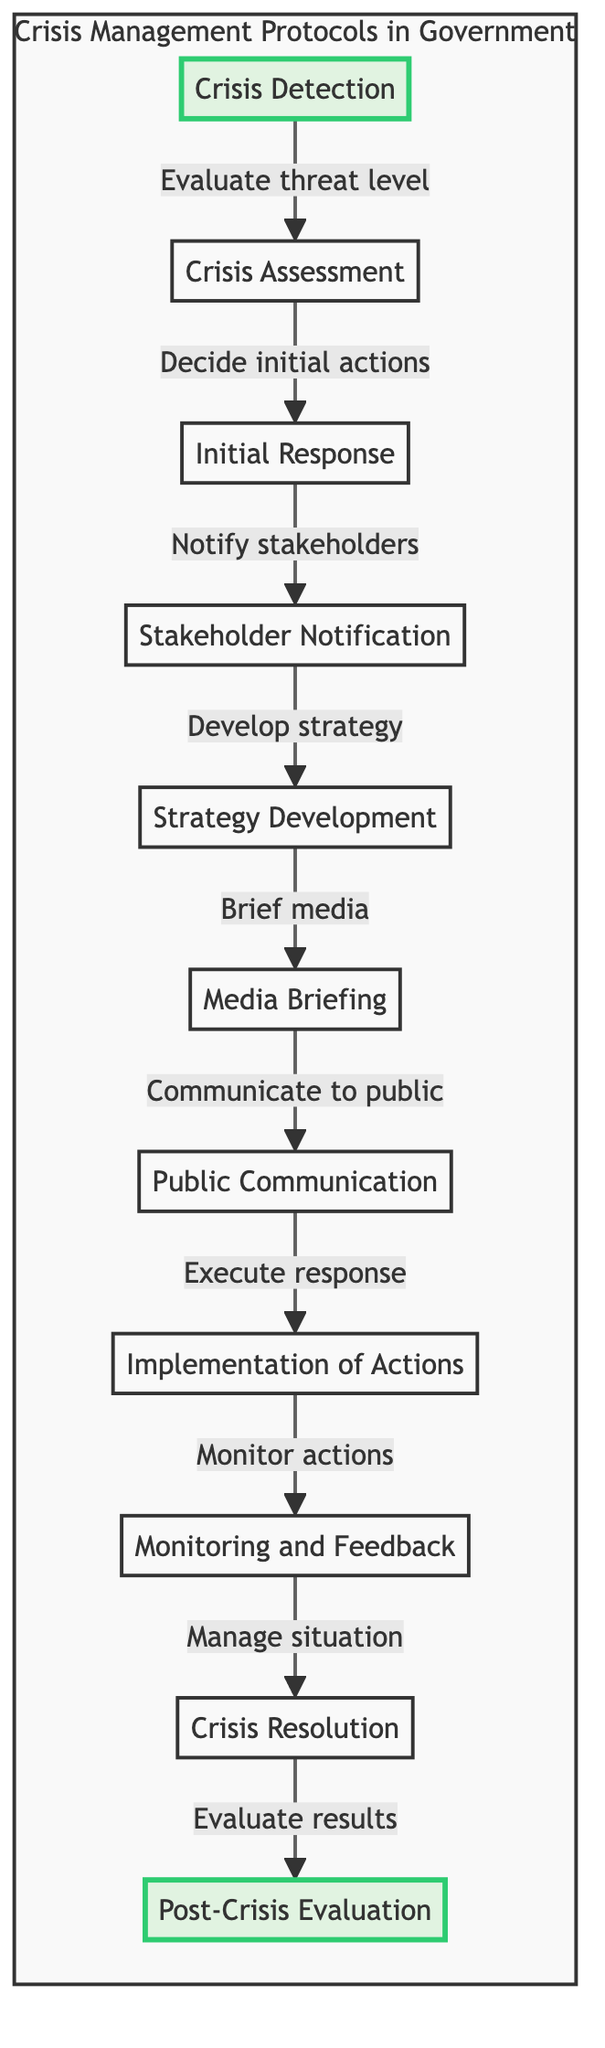What is the first step in the crisis management protocol? The first step in the diagram is labeled as "Crisis Detection," indicating that recognizing a potential crisis is the initial action taken.
Answer: Crisis Detection What step follows "Crisis Assessment"? According to the flow, after "Crisis Assessment," the next step is "Initial Response," which represents the actions taken after assessing the situation.
Answer: Initial Response How many total steps are shown in the diagram? To determine the total steps, we count all the nodes in the flowchart. There are eleven distinct steps from "Crisis Detection" to "Post-Crisis Evaluation."
Answer: 11 Which steps involve communication with external parties? The steps involving communication with external parties are "Media Briefing" and "Public Communication," as they both entail informing media and the public respectively about the crisis response.
Answer: Media Briefing, Public Communication What action must be taken immediately after "Notify stakeholders"? Following "Notify stakeholders," the next action as per the diagram is "Strategy Development," wherein specific strategies are crafted based on the notifications made.
Answer: Strategy Development Which node is highlighted in the diagram? The diagram highlights the first and the last steps, specifically "Crisis Detection" and "Post-Crisis Evaluation," to emphasize their importance in the overall protocol.
Answer: Crisis Detection, Post-Crisis Evaluation What action comes before "Crisis Resolution"? The action that occurs right before "Crisis Resolution" is "Monitor actions," which focuses on overseeing the implementation and efficacy of the response during the crisis.
Answer: Monitor actions What is the final step in the crisis management protocol? The last step in the diagram is "Post-Crisis Evaluation," which signifies the assessment and analysis of the crisis management process after the crisis has been resolved.
Answer: Post-Crisis Evaluation What is the main objective of the "Strategy Development" step? The goal of "Strategy Development" is to create a coherent plan and methods to handle the crisis effectively, ensuring the government can respond adequately.
Answer: Develop strategy What is the term used for the actions that take place after “Execute response”? The actions that follow "Execute response" are referred to in the diagram as "Monitoring and Feedback," indicating a continual oversight process after the initial response is put into effect.
Answer: Monitoring and Feedback 